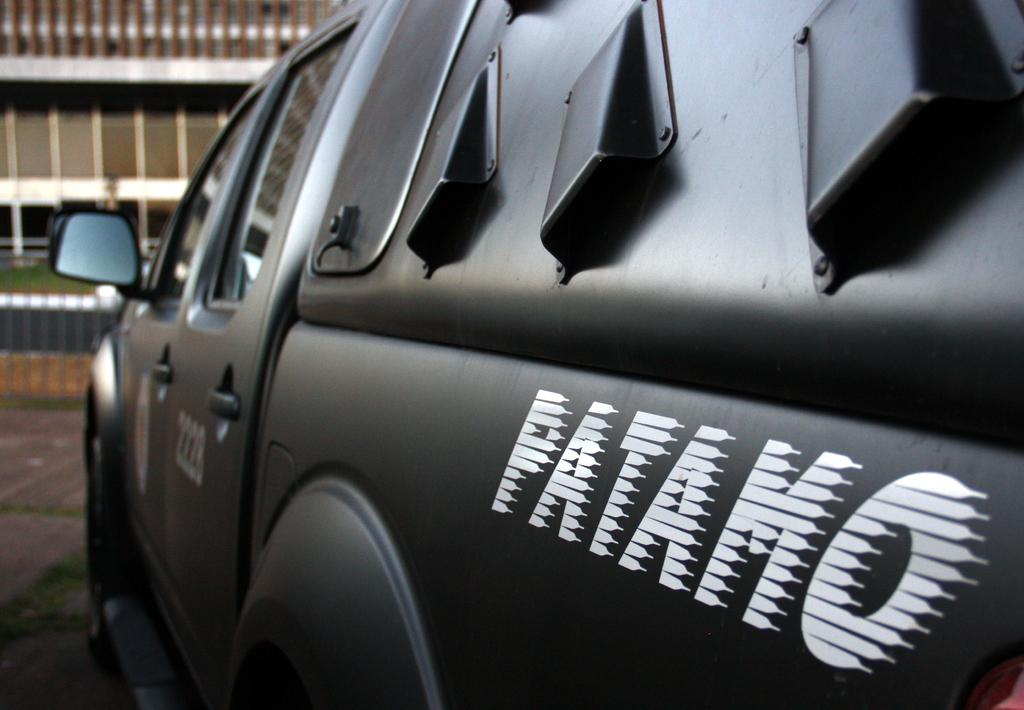What color is the truck in the image? The truck in the image is black. What else can be seen in the image besides the truck? There are buildings in the image. Can you tell me how many geese are arguing about the cream in the image? There are no geese or cream present in the image; it features a black color truck and buildings. 